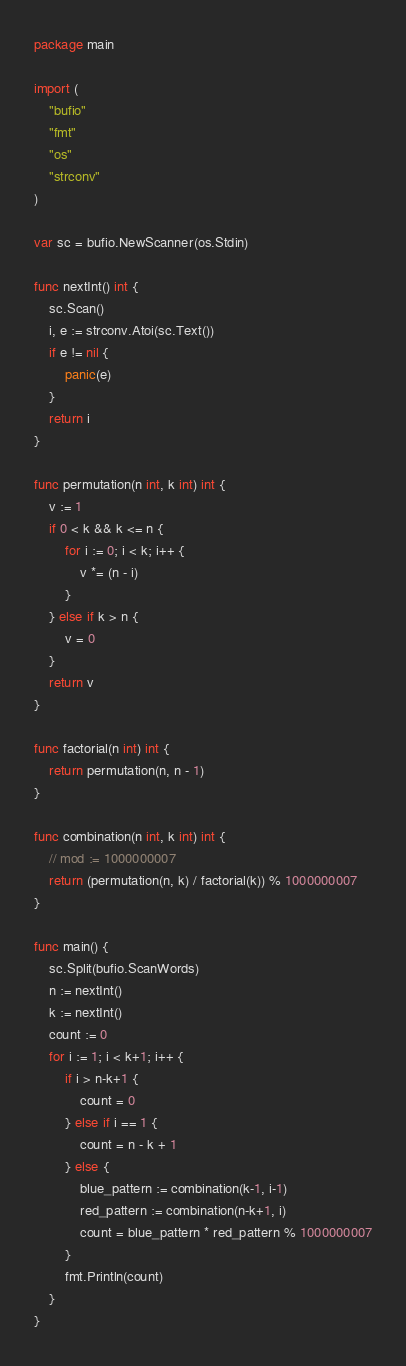<code> <loc_0><loc_0><loc_500><loc_500><_Go_>package main

import (
	"bufio"
	"fmt"
	"os"
	"strconv"
)

var sc = bufio.NewScanner(os.Stdin)

func nextInt() int {
	sc.Scan()
	i, e := strconv.Atoi(sc.Text())
	if e != nil {
		panic(e)
	}
	return i
}

func permutation(n int, k int) int {
    v := 1
    if 0 < k && k <= n {
        for i := 0; i < k; i++ {
            v *= (n - i)
        }
    } else if k > n {
        v = 0
    }
    return v
}

func factorial(n int) int {
    return permutation(n, n - 1)
}

func combination(n int, k int) int {
	// mod := 1000000007
    return (permutation(n, k) / factorial(k)) % 1000000007
}

func main() {
	sc.Split(bufio.ScanWords)
	n := nextInt()
	k := nextInt()
	count := 0
	for i := 1; i < k+1; i++ {
		if i > n-k+1 {
			count = 0
		} else if i == 1 {
			count = n - k + 1
		} else {
			blue_pattern := combination(k-1, i-1)
			red_pattern := combination(n-k+1, i)
			count = blue_pattern * red_pattern % 1000000007
		}
		fmt.Println(count)
	}
}
</code> 